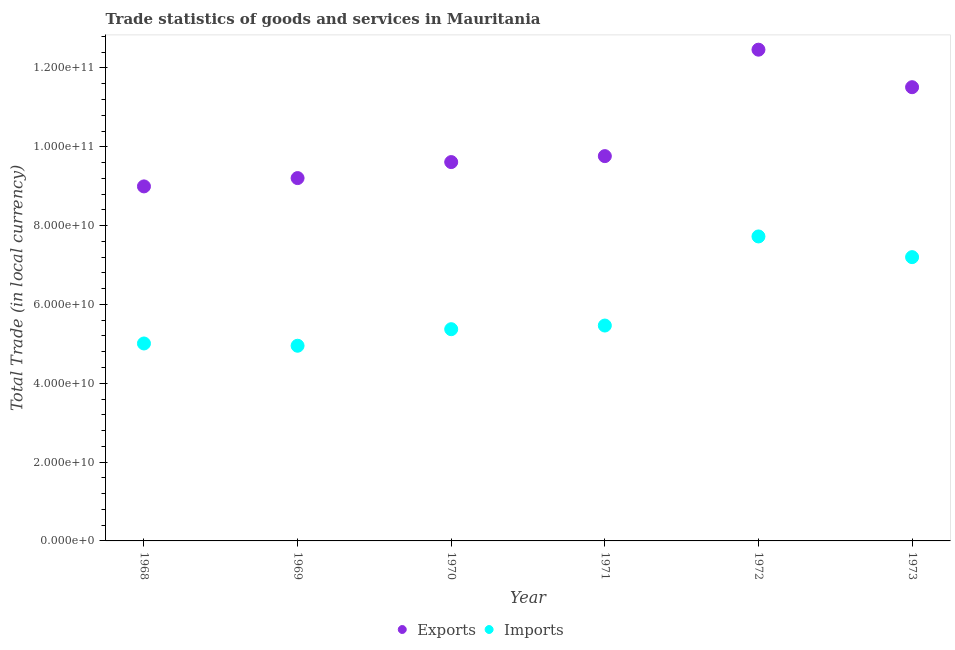How many different coloured dotlines are there?
Offer a terse response. 2. Is the number of dotlines equal to the number of legend labels?
Give a very brief answer. Yes. What is the imports of goods and services in 1970?
Your response must be concise. 5.37e+1. Across all years, what is the maximum export of goods and services?
Offer a terse response. 1.25e+11. Across all years, what is the minimum imports of goods and services?
Provide a short and direct response. 4.95e+1. In which year was the imports of goods and services maximum?
Provide a succinct answer. 1972. In which year was the export of goods and services minimum?
Your answer should be very brief. 1968. What is the total export of goods and services in the graph?
Provide a succinct answer. 6.16e+11. What is the difference between the imports of goods and services in 1970 and that in 1971?
Offer a very short reply. -9.25e+08. What is the difference between the export of goods and services in 1973 and the imports of goods and services in 1971?
Offer a terse response. 6.05e+1. What is the average export of goods and services per year?
Make the answer very short. 1.03e+11. In the year 1973, what is the difference between the imports of goods and services and export of goods and services?
Your answer should be compact. -4.31e+1. What is the ratio of the imports of goods and services in 1971 to that in 1973?
Offer a terse response. 0.76. What is the difference between the highest and the second highest imports of goods and services?
Provide a short and direct response. 5.25e+09. What is the difference between the highest and the lowest imports of goods and services?
Offer a terse response. 2.77e+1. Are the values on the major ticks of Y-axis written in scientific E-notation?
Offer a very short reply. Yes. Does the graph contain any zero values?
Provide a short and direct response. No. Where does the legend appear in the graph?
Keep it short and to the point. Bottom center. How are the legend labels stacked?
Give a very brief answer. Horizontal. What is the title of the graph?
Provide a succinct answer. Trade statistics of goods and services in Mauritania. What is the label or title of the X-axis?
Make the answer very short. Year. What is the label or title of the Y-axis?
Give a very brief answer. Total Trade (in local currency). What is the Total Trade (in local currency) of Exports in 1968?
Your response must be concise. 8.99e+1. What is the Total Trade (in local currency) of Imports in 1968?
Provide a succinct answer. 5.01e+1. What is the Total Trade (in local currency) in Exports in 1969?
Give a very brief answer. 9.21e+1. What is the Total Trade (in local currency) in Imports in 1969?
Provide a succinct answer. 4.95e+1. What is the Total Trade (in local currency) of Exports in 1970?
Give a very brief answer. 9.61e+1. What is the Total Trade (in local currency) in Imports in 1970?
Offer a terse response. 5.37e+1. What is the Total Trade (in local currency) in Exports in 1971?
Provide a succinct answer. 9.76e+1. What is the Total Trade (in local currency) in Imports in 1971?
Make the answer very short. 5.46e+1. What is the Total Trade (in local currency) in Exports in 1972?
Your response must be concise. 1.25e+11. What is the Total Trade (in local currency) of Imports in 1972?
Give a very brief answer. 7.73e+1. What is the Total Trade (in local currency) in Exports in 1973?
Keep it short and to the point. 1.15e+11. What is the Total Trade (in local currency) of Imports in 1973?
Your answer should be very brief. 7.20e+1. Across all years, what is the maximum Total Trade (in local currency) of Exports?
Give a very brief answer. 1.25e+11. Across all years, what is the maximum Total Trade (in local currency) in Imports?
Make the answer very short. 7.73e+1. Across all years, what is the minimum Total Trade (in local currency) in Exports?
Your answer should be very brief. 8.99e+1. Across all years, what is the minimum Total Trade (in local currency) in Imports?
Your response must be concise. 4.95e+1. What is the total Total Trade (in local currency) of Exports in the graph?
Provide a short and direct response. 6.16e+11. What is the total Total Trade (in local currency) of Imports in the graph?
Your answer should be compact. 3.57e+11. What is the difference between the Total Trade (in local currency) of Exports in 1968 and that in 1969?
Offer a very short reply. -2.11e+09. What is the difference between the Total Trade (in local currency) of Imports in 1968 and that in 1969?
Your response must be concise. 5.76e+08. What is the difference between the Total Trade (in local currency) of Exports in 1968 and that in 1970?
Give a very brief answer. -6.17e+09. What is the difference between the Total Trade (in local currency) of Imports in 1968 and that in 1970?
Make the answer very short. -3.63e+09. What is the difference between the Total Trade (in local currency) in Exports in 1968 and that in 1971?
Provide a short and direct response. -7.68e+09. What is the difference between the Total Trade (in local currency) in Imports in 1968 and that in 1971?
Keep it short and to the point. -4.55e+09. What is the difference between the Total Trade (in local currency) of Exports in 1968 and that in 1972?
Provide a short and direct response. -3.47e+1. What is the difference between the Total Trade (in local currency) in Imports in 1968 and that in 1972?
Keep it short and to the point. -2.72e+1. What is the difference between the Total Trade (in local currency) in Exports in 1968 and that in 1973?
Provide a succinct answer. -2.52e+1. What is the difference between the Total Trade (in local currency) in Imports in 1968 and that in 1973?
Your response must be concise. -2.19e+1. What is the difference between the Total Trade (in local currency) in Exports in 1969 and that in 1970?
Ensure brevity in your answer.  -4.06e+09. What is the difference between the Total Trade (in local currency) in Imports in 1969 and that in 1970?
Ensure brevity in your answer.  -4.20e+09. What is the difference between the Total Trade (in local currency) of Exports in 1969 and that in 1971?
Ensure brevity in your answer.  -5.58e+09. What is the difference between the Total Trade (in local currency) in Imports in 1969 and that in 1971?
Give a very brief answer. -5.13e+09. What is the difference between the Total Trade (in local currency) in Exports in 1969 and that in 1972?
Ensure brevity in your answer.  -3.26e+1. What is the difference between the Total Trade (in local currency) in Imports in 1969 and that in 1972?
Give a very brief answer. -2.77e+1. What is the difference between the Total Trade (in local currency) of Exports in 1969 and that in 1973?
Your answer should be very brief. -2.31e+1. What is the difference between the Total Trade (in local currency) in Imports in 1969 and that in 1973?
Keep it short and to the point. -2.25e+1. What is the difference between the Total Trade (in local currency) of Exports in 1970 and that in 1971?
Your response must be concise. -1.51e+09. What is the difference between the Total Trade (in local currency) of Imports in 1970 and that in 1971?
Offer a terse response. -9.25e+08. What is the difference between the Total Trade (in local currency) in Exports in 1970 and that in 1972?
Offer a very short reply. -2.85e+1. What is the difference between the Total Trade (in local currency) of Imports in 1970 and that in 1972?
Keep it short and to the point. -2.35e+1. What is the difference between the Total Trade (in local currency) in Exports in 1970 and that in 1973?
Make the answer very short. -1.90e+1. What is the difference between the Total Trade (in local currency) of Imports in 1970 and that in 1973?
Make the answer very short. -1.83e+1. What is the difference between the Total Trade (in local currency) of Exports in 1971 and that in 1972?
Ensure brevity in your answer.  -2.70e+1. What is the difference between the Total Trade (in local currency) of Imports in 1971 and that in 1972?
Your answer should be very brief. -2.26e+1. What is the difference between the Total Trade (in local currency) in Exports in 1971 and that in 1973?
Give a very brief answer. -1.75e+1. What is the difference between the Total Trade (in local currency) in Imports in 1971 and that in 1973?
Your response must be concise. -1.74e+1. What is the difference between the Total Trade (in local currency) in Exports in 1972 and that in 1973?
Your answer should be very brief. 9.52e+09. What is the difference between the Total Trade (in local currency) in Imports in 1972 and that in 1973?
Give a very brief answer. 5.25e+09. What is the difference between the Total Trade (in local currency) of Exports in 1968 and the Total Trade (in local currency) of Imports in 1969?
Offer a terse response. 4.04e+1. What is the difference between the Total Trade (in local currency) in Exports in 1968 and the Total Trade (in local currency) in Imports in 1970?
Keep it short and to the point. 3.62e+1. What is the difference between the Total Trade (in local currency) of Exports in 1968 and the Total Trade (in local currency) of Imports in 1971?
Your response must be concise. 3.53e+1. What is the difference between the Total Trade (in local currency) of Exports in 1968 and the Total Trade (in local currency) of Imports in 1972?
Keep it short and to the point. 1.27e+1. What is the difference between the Total Trade (in local currency) in Exports in 1968 and the Total Trade (in local currency) in Imports in 1973?
Keep it short and to the point. 1.79e+1. What is the difference between the Total Trade (in local currency) of Exports in 1969 and the Total Trade (in local currency) of Imports in 1970?
Keep it short and to the point. 3.83e+1. What is the difference between the Total Trade (in local currency) in Exports in 1969 and the Total Trade (in local currency) in Imports in 1971?
Your answer should be very brief. 3.74e+1. What is the difference between the Total Trade (in local currency) of Exports in 1969 and the Total Trade (in local currency) of Imports in 1972?
Your response must be concise. 1.48e+1. What is the difference between the Total Trade (in local currency) in Exports in 1969 and the Total Trade (in local currency) in Imports in 1973?
Keep it short and to the point. 2.01e+1. What is the difference between the Total Trade (in local currency) of Exports in 1970 and the Total Trade (in local currency) of Imports in 1971?
Your answer should be compact. 4.15e+1. What is the difference between the Total Trade (in local currency) in Exports in 1970 and the Total Trade (in local currency) in Imports in 1972?
Give a very brief answer. 1.89e+1. What is the difference between the Total Trade (in local currency) in Exports in 1970 and the Total Trade (in local currency) in Imports in 1973?
Offer a terse response. 2.41e+1. What is the difference between the Total Trade (in local currency) of Exports in 1971 and the Total Trade (in local currency) of Imports in 1972?
Ensure brevity in your answer.  2.04e+1. What is the difference between the Total Trade (in local currency) of Exports in 1971 and the Total Trade (in local currency) of Imports in 1973?
Provide a short and direct response. 2.56e+1. What is the difference between the Total Trade (in local currency) of Exports in 1972 and the Total Trade (in local currency) of Imports in 1973?
Ensure brevity in your answer.  5.26e+1. What is the average Total Trade (in local currency) in Exports per year?
Make the answer very short. 1.03e+11. What is the average Total Trade (in local currency) in Imports per year?
Keep it short and to the point. 5.95e+1. In the year 1968, what is the difference between the Total Trade (in local currency) in Exports and Total Trade (in local currency) in Imports?
Make the answer very short. 3.99e+1. In the year 1969, what is the difference between the Total Trade (in local currency) of Exports and Total Trade (in local currency) of Imports?
Ensure brevity in your answer.  4.25e+1. In the year 1970, what is the difference between the Total Trade (in local currency) of Exports and Total Trade (in local currency) of Imports?
Your response must be concise. 4.24e+1. In the year 1971, what is the difference between the Total Trade (in local currency) of Exports and Total Trade (in local currency) of Imports?
Offer a very short reply. 4.30e+1. In the year 1972, what is the difference between the Total Trade (in local currency) in Exports and Total Trade (in local currency) in Imports?
Your response must be concise. 4.74e+1. In the year 1973, what is the difference between the Total Trade (in local currency) of Exports and Total Trade (in local currency) of Imports?
Give a very brief answer. 4.31e+1. What is the ratio of the Total Trade (in local currency) in Exports in 1968 to that in 1969?
Provide a short and direct response. 0.98. What is the ratio of the Total Trade (in local currency) in Imports in 1968 to that in 1969?
Make the answer very short. 1.01. What is the ratio of the Total Trade (in local currency) in Exports in 1968 to that in 1970?
Your answer should be very brief. 0.94. What is the ratio of the Total Trade (in local currency) of Imports in 1968 to that in 1970?
Provide a succinct answer. 0.93. What is the ratio of the Total Trade (in local currency) of Exports in 1968 to that in 1971?
Keep it short and to the point. 0.92. What is the ratio of the Total Trade (in local currency) in Imports in 1968 to that in 1971?
Your response must be concise. 0.92. What is the ratio of the Total Trade (in local currency) in Exports in 1968 to that in 1972?
Offer a terse response. 0.72. What is the ratio of the Total Trade (in local currency) in Imports in 1968 to that in 1972?
Provide a succinct answer. 0.65. What is the ratio of the Total Trade (in local currency) in Exports in 1968 to that in 1973?
Keep it short and to the point. 0.78. What is the ratio of the Total Trade (in local currency) in Imports in 1968 to that in 1973?
Offer a terse response. 0.7. What is the ratio of the Total Trade (in local currency) in Exports in 1969 to that in 1970?
Your answer should be compact. 0.96. What is the ratio of the Total Trade (in local currency) in Imports in 1969 to that in 1970?
Your answer should be compact. 0.92. What is the ratio of the Total Trade (in local currency) of Exports in 1969 to that in 1971?
Your response must be concise. 0.94. What is the ratio of the Total Trade (in local currency) in Imports in 1969 to that in 1971?
Your answer should be very brief. 0.91. What is the ratio of the Total Trade (in local currency) of Exports in 1969 to that in 1972?
Give a very brief answer. 0.74. What is the ratio of the Total Trade (in local currency) of Imports in 1969 to that in 1972?
Your response must be concise. 0.64. What is the ratio of the Total Trade (in local currency) of Exports in 1969 to that in 1973?
Offer a very short reply. 0.8. What is the ratio of the Total Trade (in local currency) of Imports in 1969 to that in 1973?
Ensure brevity in your answer.  0.69. What is the ratio of the Total Trade (in local currency) in Exports in 1970 to that in 1971?
Provide a succinct answer. 0.98. What is the ratio of the Total Trade (in local currency) in Imports in 1970 to that in 1971?
Your answer should be very brief. 0.98. What is the ratio of the Total Trade (in local currency) of Exports in 1970 to that in 1972?
Keep it short and to the point. 0.77. What is the ratio of the Total Trade (in local currency) in Imports in 1970 to that in 1972?
Your response must be concise. 0.7. What is the ratio of the Total Trade (in local currency) in Exports in 1970 to that in 1973?
Your response must be concise. 0.83. What is the ratio of the Total Trade (in local currency) of Imports in 1970 to that in 1973?
Make the answer very short. 0.75. What is the ratio of the Total Trade (in local currency) of Exports in 1971 to that in 1972?
Give a very brief answer. 0.78. What is the ratio of the Total Trade (in local currency) of Imports in 1971 to that in 1972?
Provide a succinct answer. 0.71. What is the ratio of the Total Trade (in local currency) in Exports in 1971 to that in 1973?
Offer a terse response. 0.85. What is the ratio of the Total Trade (in local currency) in Imports in 1971 to that in 1973?
Offer a very short reply. 0.76. What is the ratio of the Total Trade (in local currency) of Exports in 1972 to that in 1973?
Ensure brevity in your answer.  1.08. What is the ratio of the Total Trade (in local currency) of Imports in 1972 to that in 1973?
Your answer should be compact. 1.07. What is the difference between the highest and the second highest Total Trade (in local currency) in Exports?
Keep it short and to the point. 9.52e+09. What is the difference between the highest and the second highest Total Trade (in local currency) of Imports?
Your answer should be compact. 5.25e+09. What is the difference between the highest and the lowest Total Trade (in local currency) of Exports?
Provide a short and direct response. 3.47e+1. What is the difference between the highest and the lowest Total Trade (in local currency) in Imports?
Keep it short and to the point. 2.77e+1. 